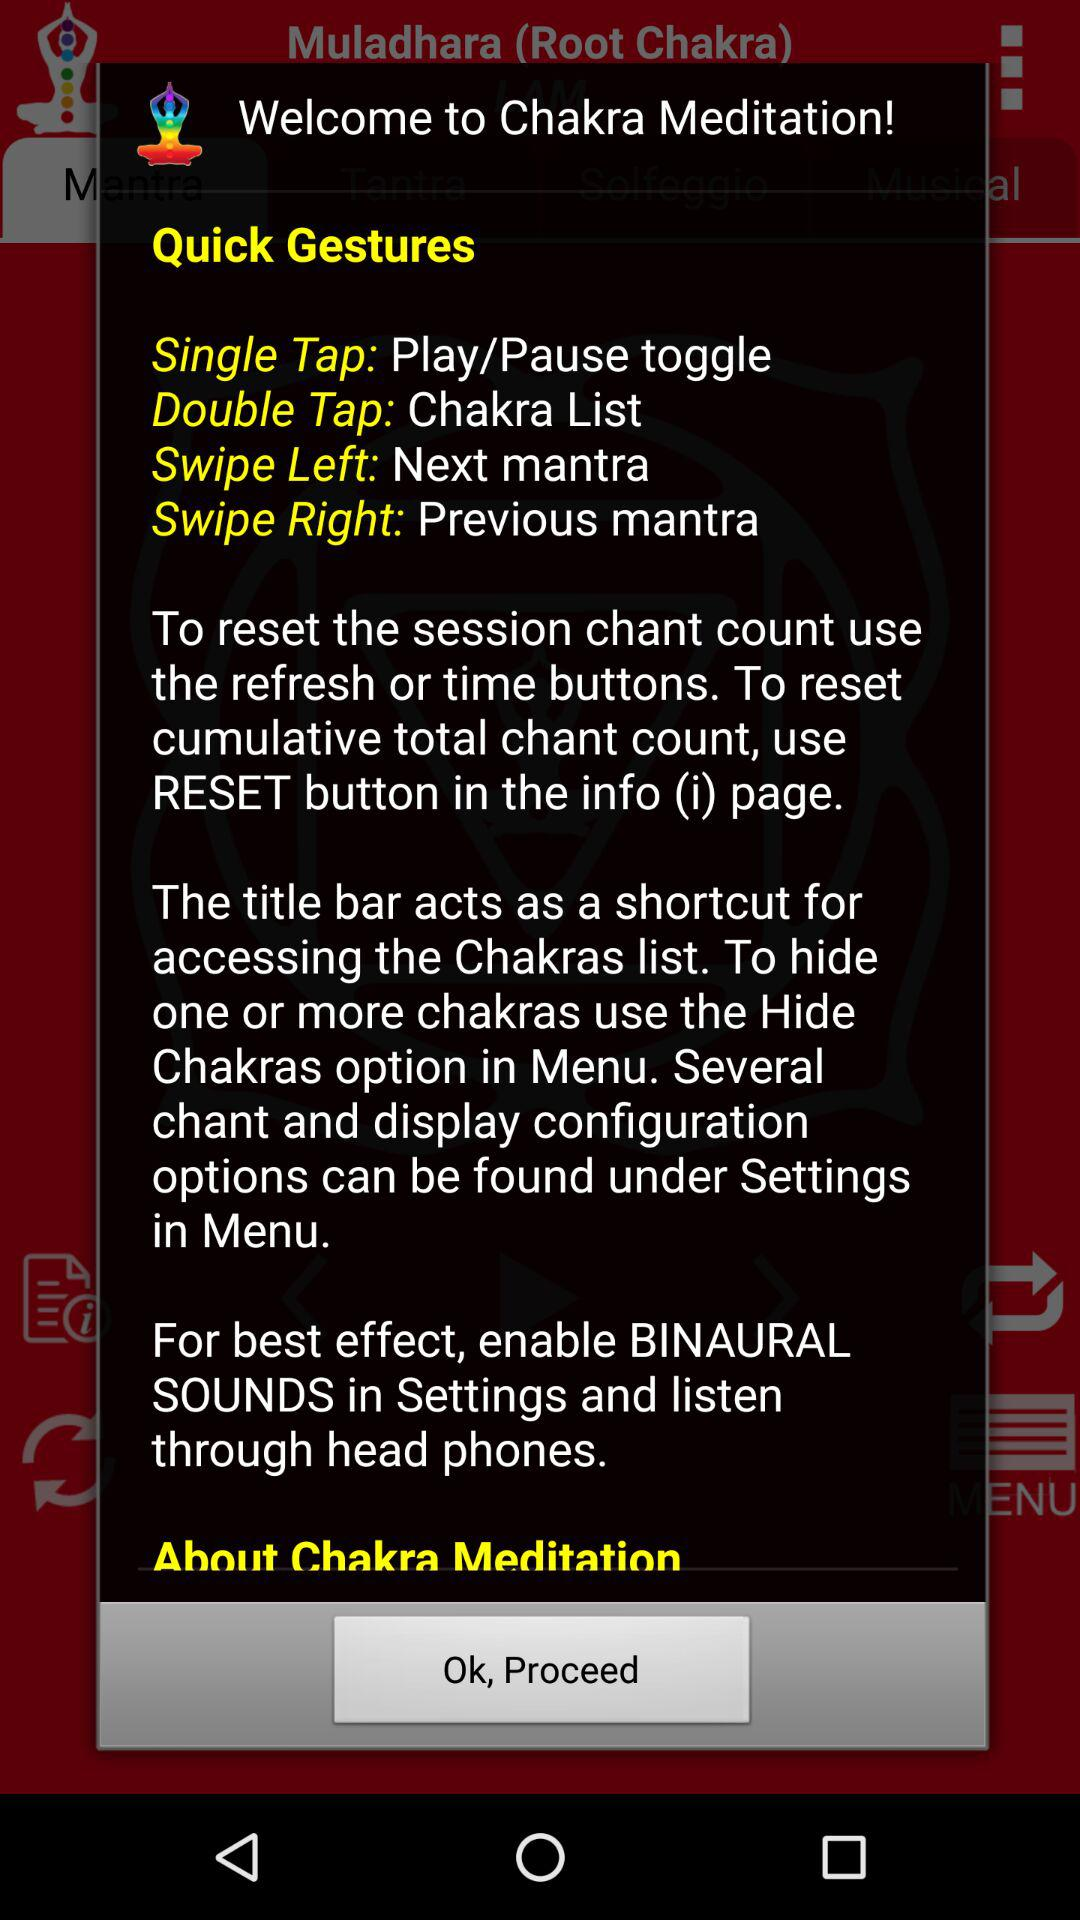How many times can the user tap the screen to switch between the mantras?
Answer the question using a single word or phrase. 3 